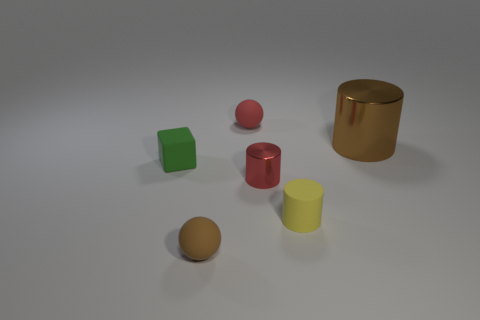What color is the thing that is behind the tiny red shiny cylinder and right of the red matte ball?
Your answer should be compact. Brown. Is there another brown matte object that has the same size as the brown matte object?
Offer a terse response. No. What size is the brown object that is behind the tiny matte thing that is in front of the tiny yellow matte thing?
Provide a succinct answer. Large. Are there fewer tiny brown matte objects left of the large brown object than large brown metallic cylinders?
Provide a succinct answer. No. What is the size of the yellow object?
Offer a terse response. Small. How many shiny cylinders have the same color as the big thing?
Your answer should be very brief. 0. There is a brown thing that is behind the rubber cylinder in front of the green thing; are there any tiny matte cylinders right of it?
Make the answer very short. No. There is a green thing that is the same size as the yellow object; what is its shape?
Keep it short and to the point. Cube. How many small things are brown shiny cylinders or red objects?
Offer a terse response. 2. What color is the small cylinder that is made of the same material as the brown ball?
Offer a very short reply. Yellow. 